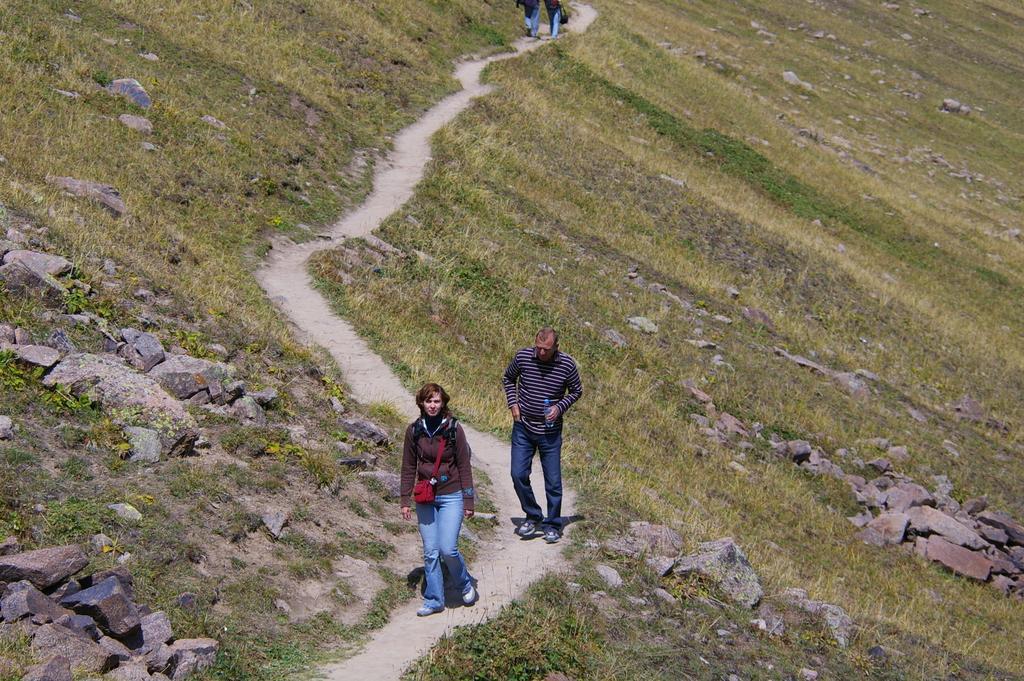Could you give a brief overview of what you see in this image? In the center of the image we can see a lady is walking and wearing a bag. And a man is walking and holding a bottle in his hand. In the background of the image we can see some rocks, grass. At the top of the image two persons are walking. In the middle of the image there is a road. 